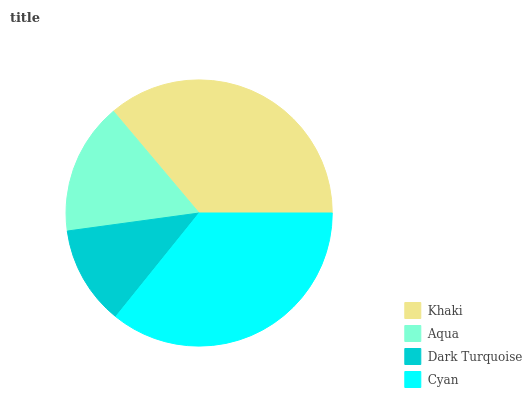Is Dark Turquoise the minimum?
Answer yes or no. Yes. Is Khaki the maximum?
Answer yes or no. Yes. Is Aqua the minimum?
Answer yes or no. No. Is Aqua the maximum?
Answer yes or no. No. Is Khaki greater than Aqua?
Answer yes or no. Yes. Is Aqua less than Khaki?
Answer yes or no. Yes. Is Aqua greater than Khaki?
Answer yes or no. No. Is Khaki less than Aqua?
Answer yes or no. No. Is Cyan the high median?
Answer yes or no. Yes. Is Aqua the low median?
Answer yes or no. Yes. Is Dark Turquoise the high median?
Answer yes or no. No. Is Khaki the low median?
Answer yes or no. No. 